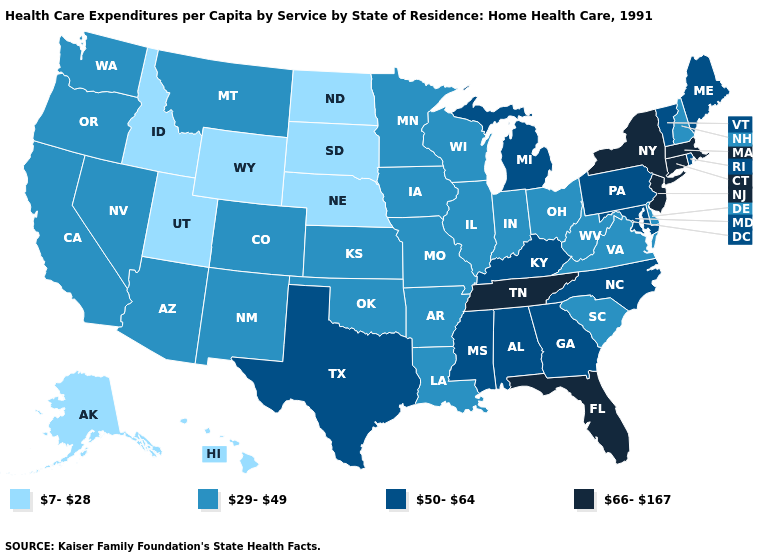What is the highest value in states that border Montana?
Short answer required. 7-28. Does the map have missing data?
Keep it brief. No. Is the legend a continuous bar?
Give a very brief answer. No. Among the states that border Oregon , which have the lowest value?
Give a very brief answer. Idaho. What is the value of Michigan?
Be succinct. 50-64. What is the lowest value in the USA?
Short answer required. 7-28. Name the states that have a value in the range 50-64?
Quick response, please. Alabama, Georgia, Kentucky, Maine, Maryland, Michigan, Mississippi, North Carolina, Pennsylvania, Rhode Island, Texas, Vermont. Does Minnesota have the same value as New York?
Be succinct. No. Which states hav the highest value in the West?
Keep it brief. Arizona, California, Colorado, Montana, Nevada, New Mexico, Oregon, Washington. Is the legend a continuous bar?
Write a very short answer. No. Name the states that have a value in the range 7-28?
Answer briefly. Alaska, Hawaii, Idaho, Nebraska, North Dakota, South Dakota, Utah, Wyoming. What is the highest value in states that border Delaware?
Short answer required. 66-167. Is the legend a continuous bar?
Short answer required. No. What is the lowest value in the USA?
Answer briefly. 7-28. Among the states that border Minnesota , does Iowa have the lowest value?
Write a very short answer. No. 